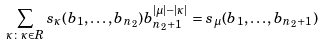Convert formula to latex. <formula><loc_0><loc_0><loc_500><loc_500>\sum _ { \kappa \colon \kappa \in R } s _ { \kappa } ( b _ { 1 } , \dots , b _ { n _ { 2 } } ) b _ { n _ { 2 } + 1 } ^ { | \mu | - | \kappa | } = s _ { \mu } ( b _ { 1 } , \dots , b _ { n _ { 2 } + 1 } )</formula> 